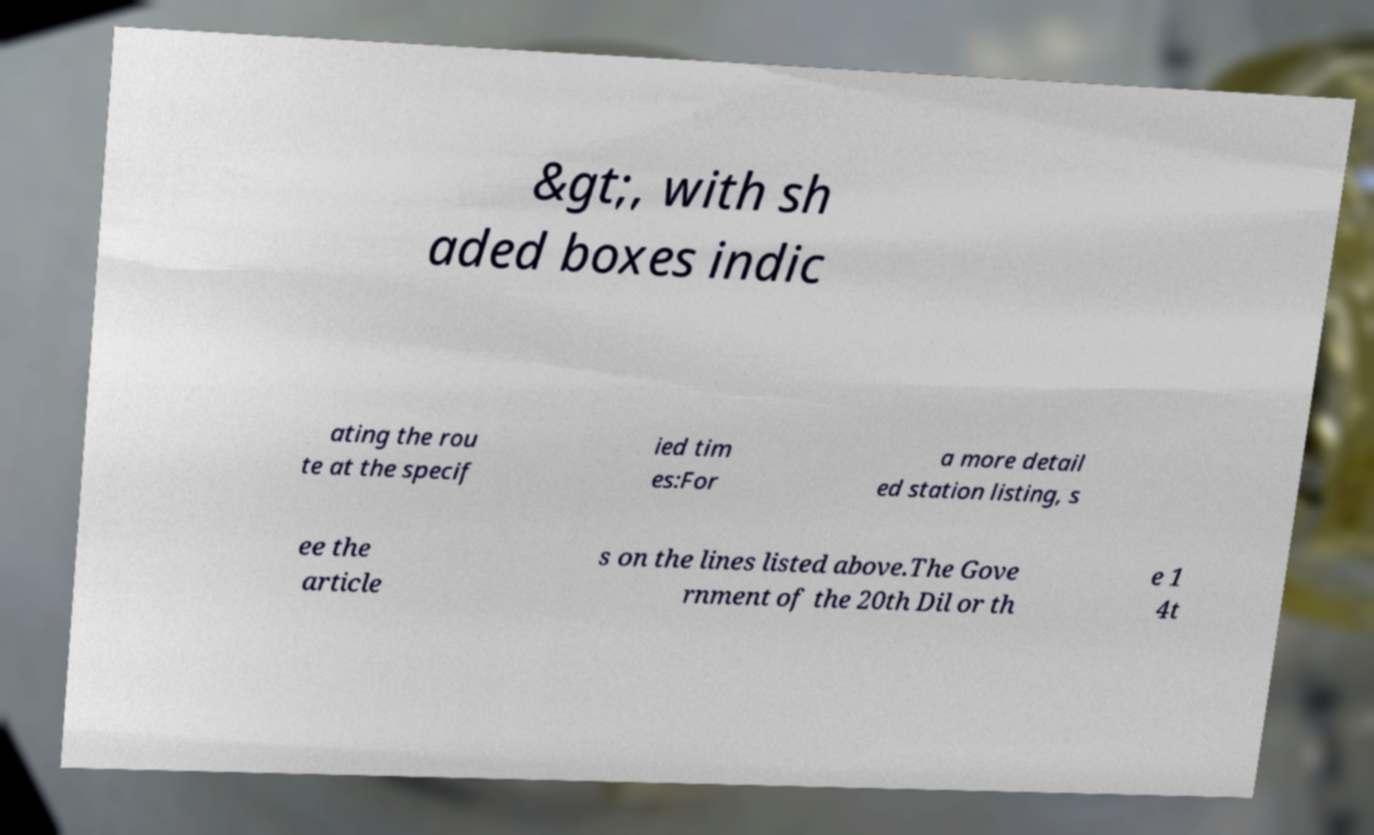Could you assist in decoding the text presented in this image and type it out clearly? &gt;, with sh aded boxes indic ating the rou te at the specif ied tim es:For a more detail ed station listing, s ee the article s on the lines listed above.The Gove rnment of the 20th Dil or th e 1 4t 